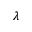Convert formula to latex. <formula><loc_0><loc_0><loc_500><loc_500>\lambda</formula> 